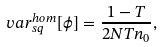Convert formula to latex. <formula><loc_0><loc_0><loc_500><loc_500>\ v a r _ { s q } ^ { h o m } [ \phi ] = \frac { 1 - T } { 2 N T n _ { 0 } } ,</formula> 